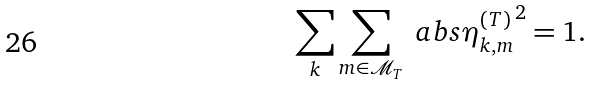<formula> <loc_0><loc_0><loc_500><loc_500>\sum _ { k } \sum _ { m \in \mathcal { M } _ { T } } \ a b s { \eta ^ { ( T ) } _ { k , m } } ^ { 2 } = 1 .</formula> 